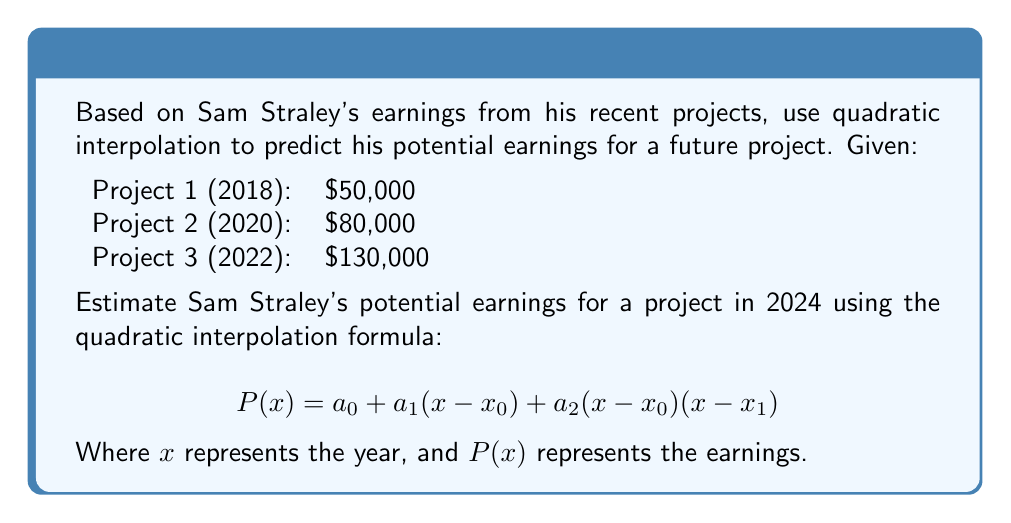Can you answer this question? To solve this problem, we'll use quadratic interpolation with the given data points. Let's follow these steps:

1. Assign variables:
   $x_0 = 2018$, $y_0 = 50,000$
   $x_1 = 2020$, $y_1 = 80,000$
   $x_2 = 2022$, $y_2 = 130,000$

2. Calculate the coefficients $a_0$, $a_1$, and $a_2$:

   $a_0 = y_0 = 50,000$

   $a_1 = \frac{y_1 - y_0}{x_1 - x_0} = \frac{80,000 - 50,000}{2020 - 2018} = 15,000$

   $a_2 = \frac{\frac{y_2 - y_1}{x_2 - x_1} - \frac{y_1 - y_0}{x_1 - x_0}}{x_2 - x_0} = \frac{\frac{130,000 - 80,000}{2022 - 2020} - \frac{80,000 - 50,000}{2020 - 2018}}{2022 - 2018} = 2,500$

3. Substitute these coefficients into the quadratic interpolation formula:

   $P(x) = 50,000 + 15,000(x-2018) + 2,500(x-2018)(x-2020)$

4. To estimate Sam Straley's earnings for 2024, substitute $x = 2024$:

   $P(2024) = 50,000 + 15,000(2024-2018) + 2,500(2024-2018)(2024-2020)$
   
   $= 50,000 + 15,000(6) + 2,500(6)(4)$
   
   $= 50,000 + 90,000 + 60,000$
   
   $= 200,000$

Therefore, using quadratic interpolation, Sam Straley's potential earnings for a project in 2024 are estimated to be $200,000.
Answer: $200,000 